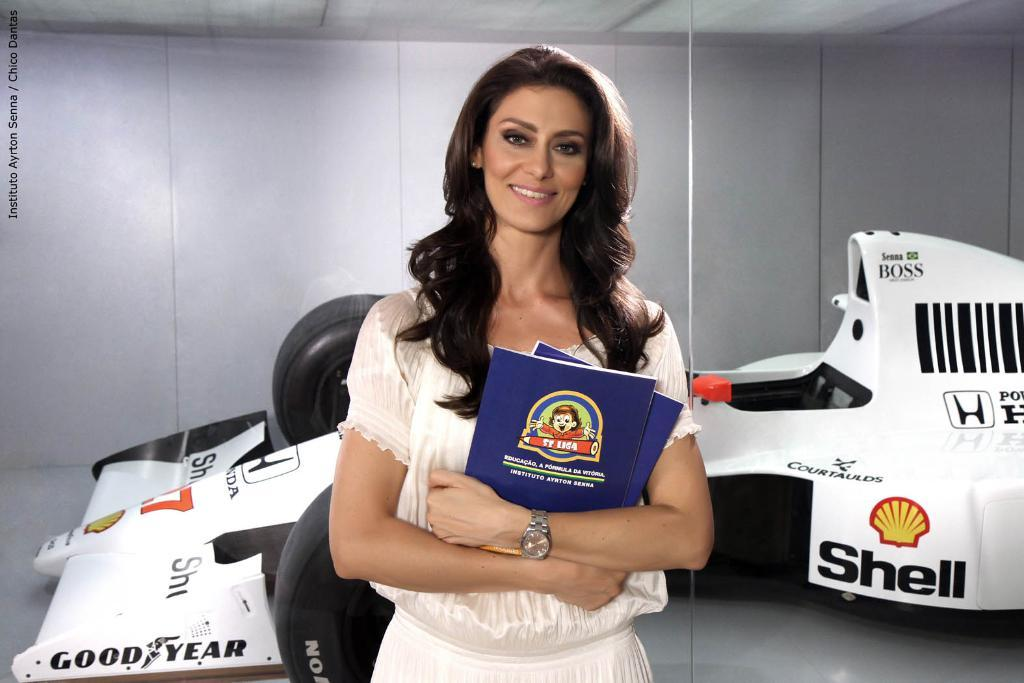Who is present in the image? There is a woman in the image. What is the woman doing in the image? The woman is smiling and holding books. What can be seen behind the woman? There is a white-colored vehicle behind the woman. What is visible in the background of the image? There is a wall in the background of the image. What advice does the woman give to the dust in the image? There is no dust present in the image, and therefore no advice can be given. 